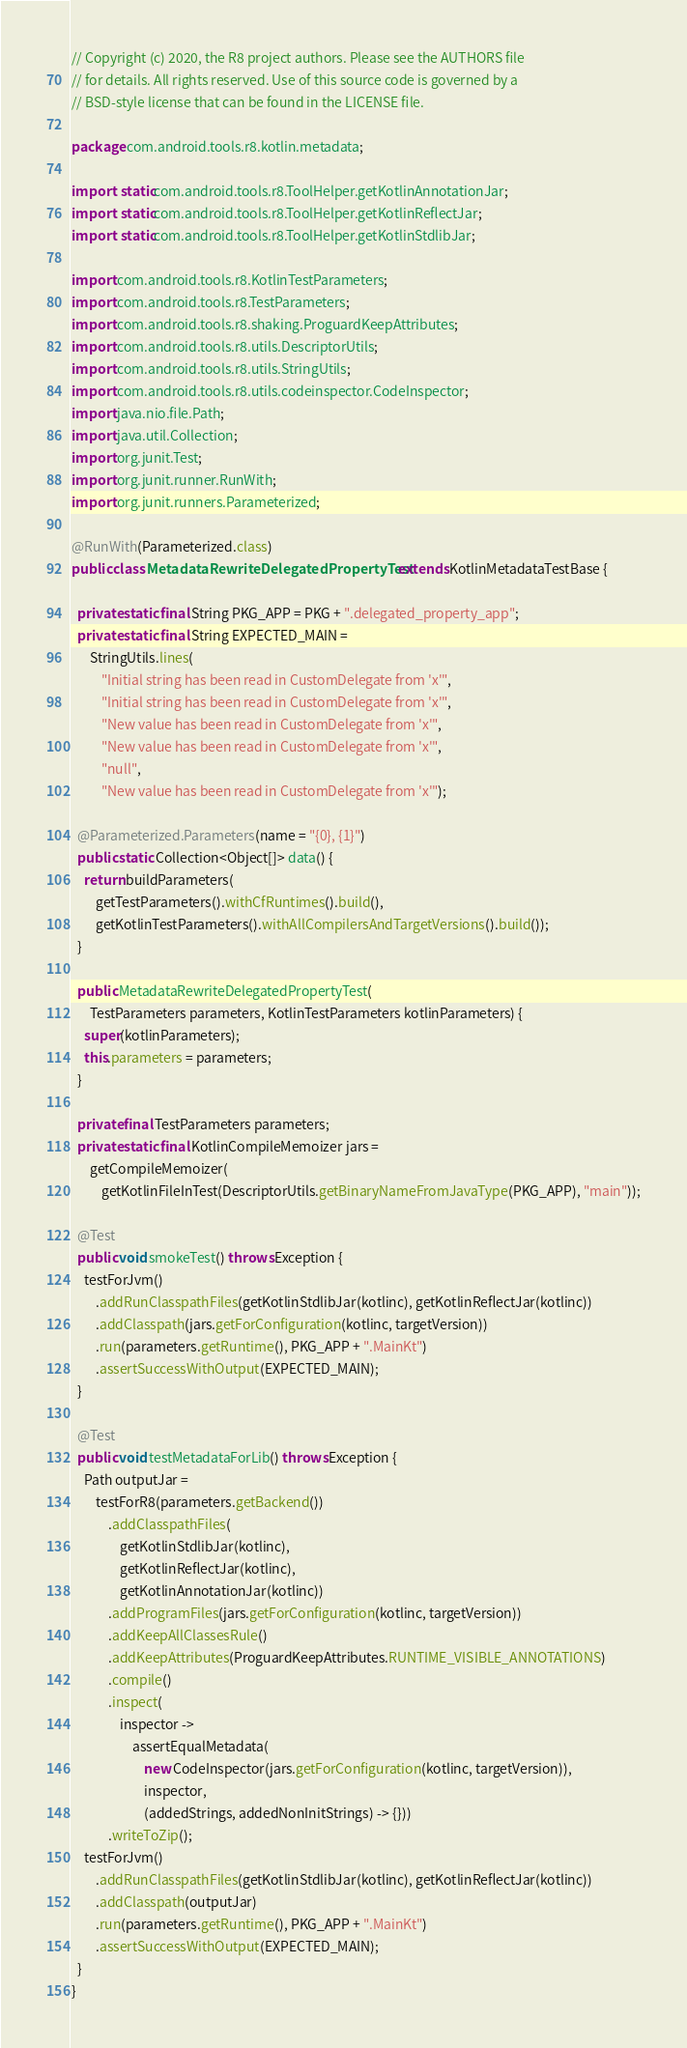<code> <loc_0><loc_0><loc_500><loc_500><_Java_>// Copyright (c) 2020, the R8 project authors. Please see the AUTHORS file
// for details. All rights reserved. Use of this source code is governed by a
// BSD-style license that can be found in the LICENSE file.

package com.android.tools.r8.kotlin.metadata;

import static com.android.tools.r8.ToolHelper.getKotlinAnnotationJar;
import static com.android.tools.r8.ToolHelper.getKotlinReflectJar;
import static com.android.tools.r8.ToolHelper.getKotlinStdlibJar;

import com.android.tools.r8.KotlinTestParameters;
import com.android.tools.r8.TestParameters;
import com.android.tools.r8.shaking.ProguardKeepAttributes;
import com.android.tools.r8.utils.DescriptorUtils;
import com.android.tools.r8.utils.StringUtils;
import com.android.tools.r8.utils.codeinspector.CodeInspector;
import java.nio.file.Path;
import java.util.Collection;
import org.junit.Test;
import org.junit.runner.RunWith;
import org.junit.runners.Parameterized;

@RunWith(Parameterized.class)
public class MetadataRewriteDelegatedPropertyTest extends KotlinMetadataTestBase {

  private static final String PKG_APP = PKG + ".delegated_property_app";
  private static final String EXPECTED_MAIN =
      StringUtils.lines(
          "Initial string has been read in CustomDelegate from 'x'",
          "Initial string has been read in CustomDelegate from 'x'",
          "New value has been read in CustomDelegate from 'x'",
          "New value has been read in CustomDelegate from 'x'",
          "null",
          "New value has been read in CustomDelegate from 'x'");

  @Parameterized.Parameters(name = "{0}, {1}")
  public static Collection<Object[]> data() {
    return buildParameters(
        getTestParameters().withCfRuntimes().build(),
        getKotlinTestParameters().withAllCompilersAndTargetVersions().build());
  }

  public MetadataRewriteDelegatedPropertyTest(
      TestParameters parameters, KotlinTestParameters kotlinParameters) {
    super(kotlinParameters);
    this.parameters = parameters;
  }

  private final TestParameters parameters;
  private static final KotlinCompileMemoizer jars =
      getCompileMemoizer(
          getKotlinFileInTest(DescriptorUtils.getBinaryNameFromJavaType(PKG_APP), "main"));

  @Test
  public void smokeTest() throws Exception {
    testForJvm()
        .addRunClasspathFiles(getKotlinStdlibJar(kotlinc), getKotlinReflectJar(kotlinc))
        .addClasspath(jars.getForConfiguration(kotlinc, targetVersion))
        .run(parameters.getRuntime(), PKG_APP + ".MainKt")
        .assertSuccessWithOutput(EXPECTED_MAIN);
  }

  @Test
  public void testMetadataForLib() throws Exception {
    Path outputJar =
        testForR8(parameters.getBackend())
            .addClasspathFiles(
                getKotlinStdlibJar(kotlinc),
                getKotlinReflectJar(kotlinc),
                getKotlinAnnotationJar(kotlinc))
            .addProgramFiles(jars.getForConfiguration(kotlinc, targetVersion))
            .addKeepAllClassesRule()
            .addKeepAttributes(ProguardKeepAttributes.RUNTIME_VISIBLE_ANNOTATIONS)
            .compile()
            .inspect(
                inspector ->
                    assertEqualMetadata(
                        new CodeInspector(jars.getForConfiguration(kotlinc, targetVersion)),
                        inspector,
                        (addedStrings, addedNonInitStrings) -> {}))
            .writeToZip();
    testForJvm()
        .addRunClasspathFiles(getKotlinStdlibJar(kotlinc), getKotlinReflectJar(kotlinc))
        .addClasspath(outputJar)
        .run(parameters.getRuntime(), PKG_APP + ".MainKt")
        .assertSuccessWithOutput(EXPECTED_MAIN);
  }
}
</code> 